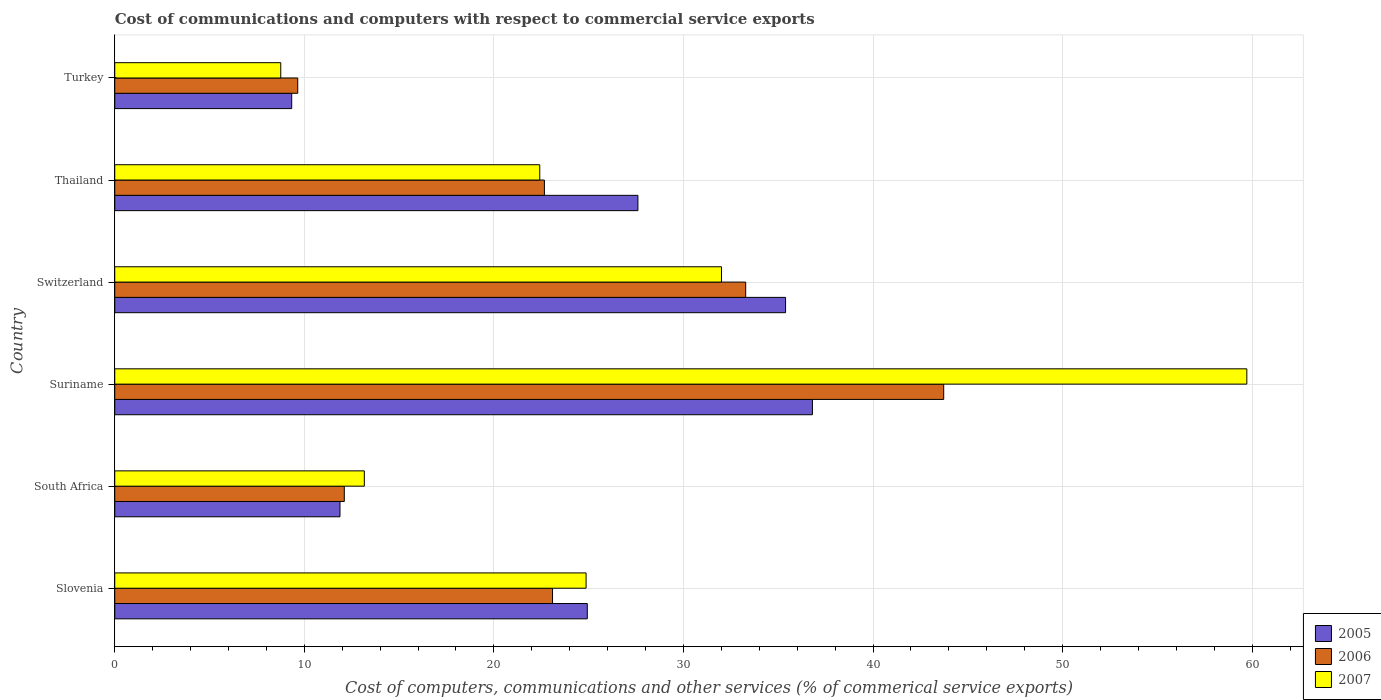How many different coloured bars are there?
Your response must be concise. 3. How many bars are there on the 4th tick from the bottom?
Make the answer very short. 3. What is the label of the 3rd group of bars from the top?
Give a very brief answer. Switzerland. What is the cost of communications and computers in 2006 in Switzerland?
Make the answer very short. 33.28. Across all countries, what is the maximum cost of communications and computers in 2005?
Your answer should be compact. 36.8. Across all countries, what is the minimum cost of communications and computers in 2007?
Your response must be concise. 8.76. In which country was the cost of communications and computers in 2007 maximum?
Ensure brevity in your answer.  Suriname. In which country was the cost of communications and computers in 2007 minimum?
Offer a very short reply. Turkey. What is the total cost of communications and computers in 2005 in the graph?
Provide a short and direct response. 145.92. What is the difference between the cost of communications and computers in 2006 in South Africa and that in Turkey?
Give a very brief answer. 2.46. What is the difference between the cost of communications and computers in 2007 in Suriname and the cost of communications and computers in 2005 in Turkey?
Offer a terse response. 50.38. What is the average cost of communications and computers in 2007 per country?
Offer a very short reply. 26.82. What is the difference between the cost of communications and computers in 2006 and cost of communications and computers in 2007 in Slovenia?
Offer a very short reply. -1.77. In how many countries, is the cost of communications and computers in 2006 greater than 14 %?
Offer a very short reply. 4. What is the ratio of the cost of communications and computers in 2006 in Switzerland to that in Turkey?
Your response must be concise. 3.45. What is the difference between the highest and the second highest cost of communications and computers in 2006?
Keep it short and to the point. 10.44. What is the difference between the highest and the lowest cost of communications and computers in 2006?
Your answer should be compact. 34.07. Is the sum of the cost of communications and computers in 2007 in South Africa and Thailand greater than the maximum cost of communications and computers in 2006 across all countries?
Make the answer very short. No. What does the 3rd bar from the bottom in South Africa represents?
Provide a short and direct response. 2007. How many bars are there?
Your response must be concise. 18. Are all the bars in the graph horizontal?
Provide a short and direct response. Yes. How many legend labels are there?
Offer a very short reply. 3. What is the title of the graph?
Your answer should be very brief. Cost of communications and computers with respect to commercial service exports. What is the label or title of the X-axis?
Give a very brief answer. Cost of computers, communications and other services (% of commerical service exports). What is the label or title of the Y-axis?
Make the answer very short. Country. What is the Cost of computers, communications and other services (% of commerical service exports) in 2005 in Slovenia?
Your answer should be compact. 24.93. What is the Cost of computers, communications and other services (% of commerical service exports) in 2006 in Slovenia?
Offer a terse response. 23.09. What is the Cost of computers, communications and other services (% of commerical service exports) of 2007 in Slovenia?
Make the answer very short. 24.86. What is the Cost of computers, communications and other services (% of commerical service exports) in 2005 in South Africa?
Ensure brevity in your answer.  11.88. What is the Cost of computers, communications and other services (% of commerical service exports) of 2006 in South Africa?
Your answer should be very brief. 12.11. What is the Cost of computers, communications and other services (% of commerical service exports) in 2007 in South Africa?
Your answer should be very brief. 13.17. What is the Cost of computers, communications and other services (% of commerical service exports) in 2005 in Suriname?
Offer a very short reply. 36.8. What is the Cost of computers, communications and other services (% of commerical service exports) of 2006 in Suriname?
Make the answer very short. 43.73. What is the Cost of computers, communications and other services (% of commerical service exports) in 2007 in Suriname?
Provide a short and direct response. 59.72. What is the Cost of computers, communications and other services (% of commerical service exports) in 2005 in Switzerland?
Give a very brief answer. 35.39. What is the Cost of computers, communications and other services (% of commerical service exports) in 2006 in Switzerland?
Provide a short and direct response. 33.28. What is the Cost of computers, communications and other services (% of commerical service exports) in 2007 in Switzerland?
Give a very brief answer. 32. What is the Cost of computers, communications and other services (% of commerical service exports) in 2005 in Thailand?
Your answer should be very brief. 27.6. What is the Cost of computers, communications and other services (% of commerical service exports) in 2006 in Thailand?
Provide a short and direct response. 22.66. What is the Cost of computers, communications and other services (% of commerical service exports) of 2007 in Thailand?
Provide a succinct answer. 22.42. What is the Cost of computers, communications and other services (% of commerical service exports) of 2005 in Turkey?
Ensure brevity in your answer.  9.33. What is the Cost of computers, communications and other services (% of commerical service exports) in 2006 in Turkey?
Your response must be concise. 9.65. What is the Cost of computers, communications and other services (% of commerical service exports) of 2007 in Turkey?
Your answer should be compact. 8.76. Across all countries, what is the maximum Cost of computers, communications and other services (% of commerical service exports) in 2005?
Keep it short and to the point. 36.8. Across all countries, what is the maximum Cost of computers, communications and other services (% of commerical service exports) of 2006?
Offer a very short reply. 43.73. Across all countries, what is the maximum Cost of computers, communications and other services (% of commerical service exports) in 2007?
Your response must be concise. 59.72. Across all countries, what is the minimum Cost of computers, communications and other services (% of commerical service exports) of 2005?
Your response must be concise. 9.33. Across all countries, what is the minimum Cost of computers, communications and other services (% of commerical service exports) of 2006?
Ensure brevity in your answer.  9.65. Across all countries, what is the minimum Cost of computers, communications and other services (% of commerical service exports) of 2007?
Ensure brevity in your answer.  8.76. What is the total Cost of computers, communications and other services (% of commerical service exports) of 2005 in the graph?
Offer a terse response. 145.92. What is the total Cost of computers, communications and other services (% of commerical service exports) of 2006 in the graph?
Your answer should be very brief. 144.53. What is the total Cost of computers, communications and other services (% of commerical service exports) in 2007 in the graph?
Provide a succinct answer. 160.92. What is the difference between the Cost of computers, communications and other services (% of commerical service exports) in 2005 in Slovenia and that in South Africa?
Ensure brevity in your answer.  13.05. What is the difference between the Cost of computers, communications and other services (% of commerical service exports) in 2006 in Slovenia and that in South Africa?
Keep it short and to the point. 10.98. What is the difference between the Cost of computers, communications and other services (% of commerical service exports) in 2007 in Slovenia and that in South Africa?
Offer a very short reply. 11.7. What is the difference between the Cost of computers, communications and other services (% of commerical service exports) in 2005 in Slovenia and that in Suriname?
Your answer should be compact. -11.88. What is the difference between the Cost of computers, communications and other services (% of commerical service exports) in 2006 in Slovenia and that in Suriname?
Your answer should be very brief. -20.63. What is the difference between the Cost of computers, communications and other services (% of commerical service exports) of 2007 in Slovenia and that in Suriname?
Ensure brevity in your answer.  -34.85. What is the difference between the Cost of computers, communications and other services (% of commerical service exports) in 2005 in Slovenia and that in Switzerland?
Give a very brief answer. -10.46. What is the difference between the Cost of computers, communications and other services (% of commerical service exports) of 2006 in Slovenia and that in Switzerland?
Ensure brevity in your answer.  -10.19. What is the difference between the Cost of computers, communications and other services (% of commerical service exports) of 2007 in Slovenia and that in Switzerland?
Offer a terse response. -7.14. What is the difference between the Cost of computers, communications and other services (% of commerical service exports) in 2005 in Slovenia and that in Thailand?
Provide a short and direct response. -2.67. What is the difference between the Cost of computers, communications and other services (% of commerical service exports) of 2006 in Slovenia and that in Thailand?
Provide a short and direct response. 0.43. What is the difference between the Cost of computers, communications and other services (% of commerical service exports) of 2007 in Slovenia and that in Thailand?
Keep it short and to the point. 2.44. What is the difference between the Cost of computers, communications and other services (% of commerical service exports) in 2005 in Slovenia and that in Turkey?
Provide a short and direct response. 15.59. What is the difference between the Cost of computers, communications and other services (% of commerical service exports) of 2006 in Slovenia and that in Turkey?
Make the answer very short. 13.44. What is the difference between the Cost of computers, communications and other services (% of commerical service exports) in 2007 in Slovenia and that in Turkey?
Provide a short and direct response. 16.11. What is the difference between the Cost of computers, communications and other services (% of commerical service exports) in 2005 in South Africa and that in Suriname?
Provide a succinct answer. -24.92. What is the difference between the Cost of computers, communications and other services (% of commerical service exports) of 2006 in South Africa and that in Suriname?
Provide a short and direct response. -31.62. What is the difference between the Cost of computers, communications and other services (% of commerical service exports) in 2007 in South Africa and that in Suriname?
Your response must be concise. -46.55. What is the difference between the Cost of computers, communications and other services (% of commerical service exports) in 2005 in South Africa and that in Switzerland?
Your response must be concise. -23.5. What is the difference between the Cost of computers, communications and other services (% of commerical service exports) in 2006 in South Africa and that in Switzerland?
Give a very brief answer. -21.17. What is the difference between the Cost of computers, communications and other services (% of commerical service exports) of 2007 in South Africa and that in Switzerland?
Make the answer very short. -18.84. What is the difference between the Cost of computers, communications and other services (% of commerical service exports) of 2005 in South Africa and that in Thailand?
Keep it short and to the point. -15.72. What is the difference between the Cost of computers, communications and other services (% of commerical service exports) of 2006 in South Africa and that in Thailand?
Make the answer very short. -10.56. What is the difference between the Cost of computers, communications and other services (% of commerical service exports) of 2007 in South Africa and that in Thailand?
Your answer should be very brief. -9.25. What is the difference between the Cost of computers, communications and other services (% of commerical service exports) of 2005 in South Africa and that in Turkey?
Provide a short and direct response. 2.55. What is the difference between the Cost of computers, communications and other services (% of commerical service exports) of 2006 in South Africa and that in Turkey?
Offer a terse response. 2.46. What is the difference between the Cost of computers, communications and other services (% of commerical service exports) in 2007 in South Africa and that in Turkey?
Ensure brevity in your answer.  4.41. What is the difference between the Cost of computers, communications and other services (% of commerical service exports) of 2005 in Suriname and that in Switzerland?
Your answer should be compact. 1.42. What is the difference between the Cost of computers, communications and other services (% of commerical service exports) in 2006 in Suriname and that in Switzerland?
Provide a succinct answer. 10.44. What is the difference between the Cost of computers, communications and other services (% of commerical service exports) in 2007 in Suriname and that in Switzerland?
Give a very brief answer. 27.71. What is the difference between the Cost of computers, communications and other services (% of commerical service exports) in 2005 in Suriname and that in Thailand?
Your answer should be very brief. 9.21. What is the difference between the Cost of computers, communications and other services (% of commerical service exports) in 2006 in Suriname and that in Thailand?
Provide a short and direct response. 21.06. What is the difference between the Cost of computers, communications and other services (% of commerical service exports) in 2007 in Suriname and that in Thailand?
Your response must be concise. 37.3. What is the difference between the Cost of computers, communications and other services (% of commerical service exports) of 2005 in Suriname and that in Turkey?
Keep it short and to the point. 27.47. What is the difference between the Cost of computers, communications and other services (% of commerical service exports) of 2006 in Suriname and that in Turkey?
Offer a very short reply. 34.07. What is the difference between the Cost of computers, communications and other services (% of commerical service exports) in 2007 in Suriname and that in Turkey?
Make the answer very short. 50.96. What is the difference between the Cost of computers, communications and other services (% of commerical service exports) in 2005 in Switzerland and that in Thailand?
Your response must be concise. 7.79. What is the difference between the Cost of computers, communications and other services (% of commerical service exports) of 2006 in Switzerland and that in Thailand?
Your response must be concise. 10.62. What is the difference between the Cost of computers, communications and other services (% of commerical service exports) in 2007 in Switzerland and that in Thailand?
Your response must be concise. 9.59. What is the difference between the Cost of computers, communications and other services (% of commerical service exports) in 2005 in Switzerland and that in Turkey?
Provide a succinct answer. 26.05. What is the difference between the Cost of computers, communications and other services (% of commerical service exports) in 2006 in Switzerland and that in Turkey?
Your answer should be very brief. 23.63. What is the difference between the Cost of computers, communications and other services (% of commerical service exports) in 2007 in Switzerland and that in Turkey?
Ensure brevity in your answer.  23.25. What is the difference between the Cost of computers, communications and other services (% of commerical service exports) of 2005 in Thailand and that in Turkey?
Your answer should be very brief. 18.26. What is the difference between the Cost of computers, communications and other services (% of commerical service exports) of 2006 in Thailand and that in Turkey?
Offer a terse response. 13.01. What is the difference between the Cost of computers, communications and other services (% of commerical service exports) of 2007 in Thailand and that in Turkey?
Ensure brevity in your answer.  13.66. What is the difference between the Cost of computers, communications and other services (% of commerical service exports) in 2005 in Slovenia and the Cost of computers, communications and other services (% of commerical service exports) in 2006 in South Africa?
Make the answer very short. 12.82. What is the difference between the Cost of computers, communications and other services (% of commerical service exports) of 2005 in Slovenia and the Cost of computers, communications and other services (% of commerical service exports) of 2007 in South Africa?
Give a very brief answer. 11.76. What is the difference between the Cost of computers, communications and other services (% of commerical service exports) of 2006 in Slovenia and the Cost of computers, communications and other services (% of commerical service exports) of 2007 in South Africa?
Make the answer very short. 9.93. What is the difference between the Cost of computers, communications and other services (% of commerical service exports) in 2005 in Slovenia and the Cost of computers, communications and other services (% of commerical service exports) in 2006 in Suriname?
Ensure brevity in your answer.  -18.8. What is the difference between the Cost of computers, communications and other services (% of commerical service exports) of 2005 in Slovenia and the Cost of computers, communications and other services (% of commerical service exports) of 2007 in Suriname?
Provide a succinct answer. -34.79. What is the difference between the Cost of computers, communications and other services (% of commerical service exports) in 2006 in Slovenia and the Cost of computers, communications and other services (% of commerical service exports) in 2007 in Suriname?
Make the answer very short. -36.62. What is the difference between the Cost of computers, communications and other services (% of commerical service exports) of 2005 in Slovenia and the Cost of computers, communications and other services (% of commerical service exports) of 2006 in Switzerland?
Offer a very short reply. -8.36. What is the difference between the Cost of computers, communications and other services (% of commerical service exports) in 2005 in Slovenia and the Cost of computers, communications and other services (% of commerical service exports) in 2007 in Switzerland?
Your response must be concise. -7.08. What is the difference between the Cost of computers, communications and other services (% of commerical service exports) in 2006 in Slovenia and the Cost of computers, communications and other services (% of commerical service exports) in 2007 in Switzerland?
Your answer should be compact. -8.91. What is the difference between the Cost of computers, communications and other services (% of commerical service exports) of 2005 in Slovenia and the Cost of computers, communications and other services (% of commerical service exports) of 2006 in Thailand?
Your answer should be compact. 2.26. What is the difference between the Cost of computers, communications and other services (% of commerical service exports) in 2005 in Slovenia and the Cost of computers, communications and other services (% of commerical service exports) in 2007 in Thailand?
Ensure brevity in your answer.  2.51. What is the difference between the Cost of computers, communications and other services (% of commerical service exports) in 2006 in Slovenia and the Cost of computers, communications and other services (% of commerical service exports) in 2007 in Thailand?
Make the answer very short. 0.67. What is the difference between the Cost of computers, communications and other services (% of commerical service exports) in 2005 in Slovenia and the Cost of computers, communications and other services (% of commerical service exports) in 2006 in Turkey?
Offer a very short reply. 15.27. What is the difference between the Cost of computers, communications and other services (% of commerical service exports) of 2005 in Slovenia and the Cost of computers, communications and other services (% of commerical service exports) of 2007 in Turkey?
Offer a terse response. 16.17. What is the difference between the Cost of computers, communications and other services (% of commerical service exports) of 2006 in Slovenia and the Cost of computers, communications and other services (% of commerical service exports) of 2007 in Turkey?
Give a very brief answer. 14.34. What is the difference between the Cost of computers, communications and other services (% of commerical service exports) in 2005 in South Africa and the Cost of computers, communications and other services (% of commerical service exports) in 2006 in Suriname?
Your answer should be compact. -31.85. What is the difference between the Cost of computers, communications and other services (% of commerical service exports) in 2005 in South Africa and the Cost of computers, communications and other services (% of commerical service exports) in 2007 in Suriname?
Your response must be concise. -47.84. What is the difference between the Cost of computers, communications and other services (% of commerical service exports) in 2006 in South Africa and the Cost of computers, communications and other services (% of commerical service exports) in 2007 in Suriname?
Offer a terse response. -47.61. What is the difference between the Cost of computers, communications and other services (% of commerical service exports) in 2005 in South Africa and the Cost of computers, communications and other services (% of commerical service exports) in 2006 in Switzerland?
Offer a terse response. -21.4. What is the difference between the Cost of computers, communications and other services (% of commerical service exports) in 2005 in South Africa and the Cost of computers, communications and other services (% of commerical service exports) in 2007 in Switzerland?
Make the answer very short. -20.12. What is the difference between the Cost of computers, communications and other services (% of commerical service exports) in 2006 in South Africa and the Cost of computers, communications and other services (% of commerical service exports) in 2007 in Switzerland?
Provide a succinct answer. -19.9. What is the difference between the Cost of computers, communications and other services (% of commerical service exports) in 2005 in South Africa and the Cost of computers, communications and other services (% of commerical service exports) in 2006 in Thailand?
Make the answer very short. -10.78. What is the difference between the Cost of computers, communications and other services (% of commerical service exports) of 2005 in South Africa and the Cost of computers, communications and other services (% of commerical service exports) of 2007 in Thailand?
Give a very brief answer. -10.54. What is the difference between the Cost of computers, communications and other services (% of commerical service exports) in 2006 in South Africa and the Cost of computers, communications and other services (% of commerical service exports) in 2007 in Thailand?
Your answer should be compact. -10.31. What is the difference between the Cost of computers, communications and other services (% of commerical service exports) in 2005 in South Africa and the Cost of computers, communications and other services (% of commerical service exports) in 2006 in Turkey?
Your answer should be compact. 2.23. What is the difference between the Cost of computers, communications and other services (% of commerical service exports) in 2005 in South Africa and the Cost of computers, communications and other services (% of commerical service exports) in 2007 in Turkey?
Give a very brief answer. 3.12. What is the difference between the Cost of computers, communications and other services (% of commerical service exports) of 2006 in South Africa and the Cost of computers, communications and other services (% of commerical service exports) of 2007 in Turkey?
Keep it short and to the point. 3.35. What is the difference between the Cost of computers, communications and other services (% of commerical service exports) of 2005 in Suriname and the Cost of computers, communications and other services (% of commerical service exports) of 2006 in Switzerland?
Provide a succinct answer. 3.52. What is the difference between the Cost of computers, communications and other services (% of commerical service exports) in 2005 in Suriname and the Cost of computers, communications and other services (% of commerical service exports) in 2007 in Switzerland?
Your answer should be very brief. 4.8. What is the difference between the Cost of computers, communications and other services (% of commerical service exports) of 2006 in Suriname and the Cost of computers, communications and other services (% of commerical service exports) of 2007 in Switzerland?
Provide a succinct answer. 11.72. What is the difference between the Cost of computers, communications and other services (% of commerical service exports) in 2005 in Suriname and the Cost of computers, communications and other services (% of commerical service exports) in 2006 in Thailand?
Provide a succinct answer. 14.14. What is the difference between the Cost of computers, communications and other services (% of commerical service exports) in 2005 in Suriname and the Cost of computers, communications and other services (% of commerical service exports) in 2007 in Thailand?
Your response must be concise. 14.38. What is the difference between the Cost of computers, communications and other services (% of commerical service exports) in 2006 in Suriname and the Cost of computers, communications and other services (% of commerical service exports) in 2007 in Thailand?
Offer a very short reply. 21.31. What is the difference between the Cost of computers, communications and other services (% of commerical service exports) of 2005 in Suriname and the Cost of computers, communications and other services (% of commerical service exports) of 2006 in Turkey?
Your response must be concise. 27.15. What is the difference between the Cost of computers, communications and other services (% of commerical service exports) in 2005 in Suriname and the Cost of computers, communications and other services (% of commerical service exports) in 2007 in Turkey?
Keep it short and to the point. 28.05. What is the difference between the Cost of computers, communications and other services (% of commerical service exports) of 2006 in Suriname and the Cost of computers, communications and other services (% of commerical service exports) of 2007 in Turkey?
Your answer should be compact. 34.97. What is the difference between the Cost of computers, communications and other services (% of commerical service exports) in 2005 in Switzerland and the Cost of computers, communications and other services (% of commerical service exports) in 2006 in Thailand?
Your answer should be very brief. 12.72. What is the difference between the Cost of computers, communications and other services (% of commerical service exports) of 2005 in Switzerland and the Cost of computers, communications and other services (% of commerical service exports) of 2007 in Thailand?
Ensure brevity in your answer.  12.97. What is the difference between the Cost of computers, communications and other services (% of commerical service exports) of 2006 in Switzerland and the Cost of computers, communications and other services (% of commerical service exports) of 2007 in Thailand?
Keep it short and to the point. 10.86. What is the difference between the Cost of computers, communications and other services (% of commerical service exports) of 2005 in Switzerland and the Cost of computers, communications and other services (% of commerical service exports) of 2006 in Turkey?
Your response must be concise. 25.73. What is the difference between the Cost of computers, communications and other services (% of commerical service exports) in 2005 in Switzerland and the Cost of computers, communications and other services (% of commerical service exports) in 2007 in Turkey?
Make the answer very short. 26.63. What is the difference between the Cost of computers, communications and other services (% of commerical service exports) in 2006 in Switzerland and the Cost of computers, communications and other services (% of commerical service exports) in 2007 in Turkey?
Give a very brief answer. 24.53. What is the difference between the Cost of computers, communications and other services (% of commerical service exports) in 2005 in Thailand and the Cost of computers, communications and other services (% of commerical service exports) in 2006 in Turkey?
Offer a very short reply. 17.94. What is the difference between the Cost of computers, communications and other services (% of commerical service exports) of 2005 in Thailand and the Cost of computers, communications and other services (% of commerical service exports) of 2007 in Turkey?
Provide a succinct answer. 18.84. What is the difference between the Cost of computers, communications and other services (% of commerical service exports) of 2006 in Thailand and the Cost of computers, communications and other services (% of commerical service exports) of 2007 in Turkey?
Offer a terse response. 13.91. What is the average Cost of computers, communications and other services (% of commerical service exports) of 2005 per country?
Keep it short and to the point. 24.32. What is the average Cost of computers, communications and other services (% of commerical service exports) of 2006 per country?
Offer a terse response. 24.09. What is the average Cost of computers, communications and other services (% of commerical service exports) in 2007 per country?
Make the answer very short. 26.82. What is the difference between the Cost of computers, communications and other services (% of commerical service exports) of 2005 and Cost of computers, communications and other services (% of commerical service exports) of 2006 in Slovenia?
Keep it short and to the point. 1.83. What is the difference between the Cost of computers, communications and other services (% of commerical service exports) in 2005 and Cost of computers, communications and other services (% of commerical service exports) in 2007 in Slovenia?
Provide a succinct answer. 0.06. What is the difference between the Cost of computers, communications and other services (% of commerical service exports) of 2006 and Cost of computers, communications and other services (% of commerical service exports) of 2007 in Slovenia?
Give a very brief answer. -1.77. What is the difference between the Cost of computers, communications and other services (% of commerical service exports) of 2005 and Cost of computers, communications and other services (% of commerical service exports) of 2006 in South Africa?
Keep it short and to the point. -0.23. What is the difference between the Cost of computers, communications and other services (% of commerical service exports) of 2005 and Cost of computers, communications and other services (% of commerical service exports) of 2007 in South Africa?
Give a very brief answer. -1.28. What is the difference between the Cost of computers, communications and other services (% of commerical service exports) in 2006 and Cost of computers, communications and other services (% of commerical service exports) in 2007 in South Africa?
Provide a short and direct response. -1.06. What is the difference between the Cost of computers, communications and other services (% of commerical service exports) in 2005 and Cost of computers, communications and other services (% of commerical service exports) in 2006 in Suriname?
Give a very brief answer. -6.92. What is the difference between the Cost of computers, communications and other services (% of commerical service exports) of 2005 and Cost of computers, communications and other services (% of commerical service exports) of 2007 in Suriname?
Provide a short and direct response. -22.91. What is the difference between the Cost of computers, communications and other services (% of commerical service exports) in 2006 and Cost of computers, communications and other services (% of commerical service exports) in 2007 in Suriname?
Provide a succinct answer. -15.99. What is the difference between the Cost of computers, communications and other services (% of commerical service exports) in 2005 and Cost of computers, communications and other services (% of commerical service exports) in 2006 in Switzerland?
Your answer should be compact. 2.1. What is the difference between the Cost of computers, communications and other services (% of commerical service exports) of 2005 and Cost of computers, communications and other services (% of commerical service exports) of 2007 in Switzerland?
Give a very brief answer. 3.38. What is the difference between the Cost of computers, communications and other services (% of commerical service exports) in 2006 and Cost of computers, communications and other services (% of commerical service exports) in 2007 in Switzerland?
Your answer should be compact. 1.28. What is the difference between the Cost of computers, communications and other services (% of commerical service exports) of 2005 and Cost of computers, communications and other services (% of commerical service exports) of 2006 in Thailand?
Your response must be concise. 4.93. What is the difference between the Cost of computers, communications and other services (% of commerical service exports) of 2005 and Cost of computers, communications and other services (% of commerical service exports) of 2007 in Thailand?
Your answer should be very brief. 5.18. What is the difference between the Cost of computers, communications and other services (% of commerical service exports) of 2006 and Cost of computers, communications and other services (% of commerical service exports) of 2007 in Thailand?
Ensure brevity in your answer.  0.25. What is the difference between the Cost of computers, communications and other services (% of commerical service exports) of 2005 and Cost of computers, communications and other services (% of commerical service exports) of 2006 in Turkey?
Provide a short and direct response. -0.32. What is the difference between the Cost of computers, communications and other services (% of commerical service exports) of 2005 and Cost of computers, communications and other services (% of commerical service exports) of 2007 in Turkey?
Provide a short and direct response. 0.58. What is the difference between the Cost of computers, communications and other services (% of commerical service exports) in 2006 and Cost of computers, communications and other services (% of commerical service exports) in 2007 in Turkey?
Keep it short and to the point. 0.9. What is the ratio of the Cost of computers, communications and other services (% of commerical service exports) in 2005 in Slovenia to that in South Africa?
Make the answer very short. 2.1. What is the ratio of the Cost of computers, communications and other services (% of commerical service exports) in 2006 in Slovenia to that in South Africa?
Your answer should be compact. 1.91. What is the ratio of the Cost of computers, communications and other services (% of commerical service exports) in 2007 in Slovenia to that in South Africa?
Your answer should be very brief. 1.89. What is the ratio of the Cost of computers, communications and other services (% of commerical service exports) of 2005 in Slovenia to that in Suriname?
Ensure brevity in your answer.  0.68. What is the ratio of the Cost of computers, communications and other services (% of commerical service exports) in 2006 in Slovenia to that in Suriname?
Provide a short and direct response. 0.53. What is the ratio of the Cost of computers, communications and other services (% of commerical service exports) of 2007 in Slovenia to that in Suriname?
Offer a very short reply. 0.42. What is the ratio of the Cost of computers, communications and other services (% of commerical service exports) of 2005 in Slovenia to that in Switzerland?
Provide a succinct answer. 0.7. What is the ratio of the Cost of computers, communications and other services (% of commerical service exports) in 2006 in Slovenia to that in Switzerland?
Your response must be concise. 0.69. What is the ratio of the Cost of computers, communications and other services (% of commerical service exports) in 2007 in Slovenia to that in Switzerland?
Make the answer very short. 0.78. What is the ratio of the Cost of computers, communications and other services (% of commerical service exports) in 2005 in Slovenia to that in Thailand?
Provide a short and direct response. 0.9. What is the ratio of the Cost of computers, communications and other services (% of commerical service exports) of 2006 in Slovenia to that in Thailand?
Make the answer very short. 1.02. What is the ratio of the Cost of computers, communications and other services (% of commerical service exports) in 2007 in Slovenia to that in Thailand?
Your response must be concise. 1.11. What is the ratio of the Cost of computers, communications and other services (% of commerical service exports) of 2005 in Slovenia to that in Turkey?
Keep it short and to the point. 2.67. What is the ratio of the Cost of computers, communications and other services (% of commerical service exports) of 2006 in Slovenia to that in Turkey?
Give a very brief answer. 2.39. What is the ratio of the Cost of computers, communications and other services (% of commerical service exports) of 2007 in Slovenia to that in Turkey?
Provide a short and direct response. 2.84. What is the ratio of the Cost of computers, communications and other services (% of commerical service exports) of 2005 in South Africa to that in Suriname?
Your answer should be very brief. 0.32. What is the ratio of the Cost of computers, communications and other services (% of commerical service exports) of 2006 in South Africa to that in Suriname?
Your response must be concise. 0.28. What is the ratio of the Cost of computers, communications and other services (% of commerical service exports) of 2007 in South Africa to that in Suriname?
Provide a short and direct response. 0.22. What is the ratio of the Cost of computers, communications and other services (% of commerical service exports) in 2005 in South Africa to that in Switzerland?
Offer a terse response. 0.34. What is the ratio of the Cost of computers, communications and other services (% of commerical service exports) of 2006 in South Africa to that in Switzerland?
Offer a very short reply. 0.36. What is the ratio of the Cost of computers, communications and other services (% of commerical service exports) of 2007 in South Africa to that in Switzerland?
Offer a very short reply. 0.41. What is the ratio of the Cost of computers, communications and other services (% of commerical service exports) of 2005 in South Africa to that in Thailand?
Your response must be concise. 0.43. What is the ratio of the Cost of computers, communications and other services (% of commerical service exports) of 2006 in South Africa to that in Thailand?
Provide a short and direct response. 0.53. What is the ratio of the Cost of computers, communications and other services (% of commerical service exports) of 2007 in South Africa to that in Thailand?
Offer a very short reply. 0.59. What is the ratio of the Cost of computers, communications and other services (% of commerical service exports) in 2005 in South Africa to that in Turkey?
Offer a very short reply. 1.27. What is the ratio of the Cost of computers, communications and other services (% of commerical service exports) in 2006 in South Africa to that in Turkey?
Your answer should be compact. 1.25. What is the ratio of the Cost of computers, communications and other services (% of commerical service exports) in 2007 in South Africa to that in Turkey?
Your answer should be compact. 1.5. What is the ratio of the Cost of computers, communications and other services (% of commerical service exports) in 2006 in Suriname to that in Switzerland?
Provide a short and direct response. 1.31. What is the ratio of the Cost of computers, communications and other services (% of commerical service exports) of 2007 in Suriname to that in Switzerland?
Your answer should be compact. 1.87. What is the ratio of the Cost of computers, communications and other services (% of commerical service exports) in 2005 in Suriname to that in Thailand?
Provide a succinct answer. 1.33. What is the ratio of the Cost of computers, communications and other services (% of commerical service exports) of 2006 in Suriname to that in Thailand?
Make the answer very short. 1.93. What is the ratio of the Cost of computers, communications and other services (% of commerical service exports) in 2007 in Suriname to that in Thailand?
Provide a succinct answer. 2.66. What is the ratio of the Cost of computers, communications and other services (% of commerical service exports) of 2005 in Suriname to that in Turkey?
Your response must be concise. 3.94. What is the ratio of the Cost of computers, communications and other services (% of commerical service exports) of 2006 in Suriname to that in Turkey?
Your answer should be compact. 4.53. What is the ratio of the Cost of computers, communications and other services (% of commerical service exports) of 2007 in Suriname to that in Turkey?
Offer a very short reply. 6.82. What is the ratio of the Cost of computers, communications and other services (% of commerical service exports) in 2005 in Switzerland to that in Thailand?
Offer a very short reply. 1.28. What is the ratio of the Cost of computers, communications and other services (% of commerical service exports) in 2006 in Switzerland to that in Thailand?
Ensure brevity in your answer.  1.47. What is the ratio of the Cost of computers, communications and other services (% of commerical service exports) of 2007 in Switzerland to that in Thailand?
Offer a very short reply. 1.43. What is the ratio of the Cost of computers, communications and other services (% of commerical service exports) of 2005 in Switzerland to that in Turkey?
Your response must be concise. 3.79. What is the ratio of the Cost of computers, communications and other services (% of commerical service exports) in 2006 in Switzerland to that in Turkey?
Your answer should be compact. 3.45. What is the ratio of the Cost of computers, communications and other services (% of commerical service exports) of 2007 in Switzerland to that in Turkey?
Make the answer very short. 3.65. What is the ratio of the Cost of computers, communications and other services (% of commerical service exports) of 2005 in Thailand to that in Turkey?
Your answer should be very brief. 2.96. What is the ratio of the Cost of computers, communications and other services (% of commerical service exports) of 2006 in Thailand to that in Turkey?
Your response must be concise. 2.35. What is the ratio of the Cost of computers, communications and other services (% of commerical service exports) of 2007 in Thailand to that in Turkey?
Offer a terse response. 2.56. What is the difference between the highest and the second highest Cost of computers, communications and other services (% of commerical service exports) of 2005?
Your answer should be compact. 1.42. What is the difference between the highest and the second highest Cost of computers, communications and other services (% of commerical service exports) in 2006?
Offer a very short reply. 10.44. What is the difference between the highest and the second highest Cost of computers, communications and other services (% of commerical service exports) of 2007?
Give a very brief answer. 27.71. What is the difference between the highest and the lowest Cost of computers, communications and other services (% of commerical service exports) of 2005?
Make the answer very short. 27.47. What is the difference between the highest and the lowest Cost of computers, communications and other services (% of commerical service exports) of 2006?
Make the answer very short. 34.07. What is the difference between the highest and the lowest Cost of computers, communications and other services (% of commerical service exports) of 2007?
Offer a terse response. 50.96. 